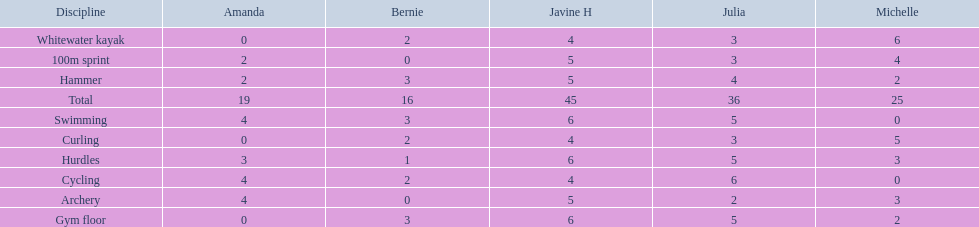Who scored the least on whitewater kayak? Amanda. 